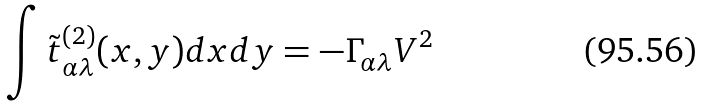Convert formula to latex. <formula><loc_0><loc_0><loc_500><loc_500>\int \tilde { t } _ { \alpha \lambda } ^ { ( 2 ) } ( { x , y } ) d { x } d { y } = - \Gamma _ { \alpha \lambda } V ^ { 2 }</formula> 